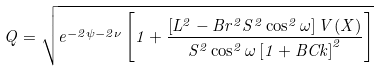Convert formula to latex. <formula><loc_0><loc_0><loc_500><loc_500>Q = \sqrt { e ^ { - 2 \psi - 2 \nu } \left [ 1 + \frac { \left [ L ^ { 2 } - B r ^ { 2 } S ^ { 2 } \cos ^ { 2 } \omega \right ] V ( X ) } { S ^ { 2 } \cos ^ { 2 } \omega \left [ 1 + B C k \right ] ^ { 2 } } \right ] }</formula> 